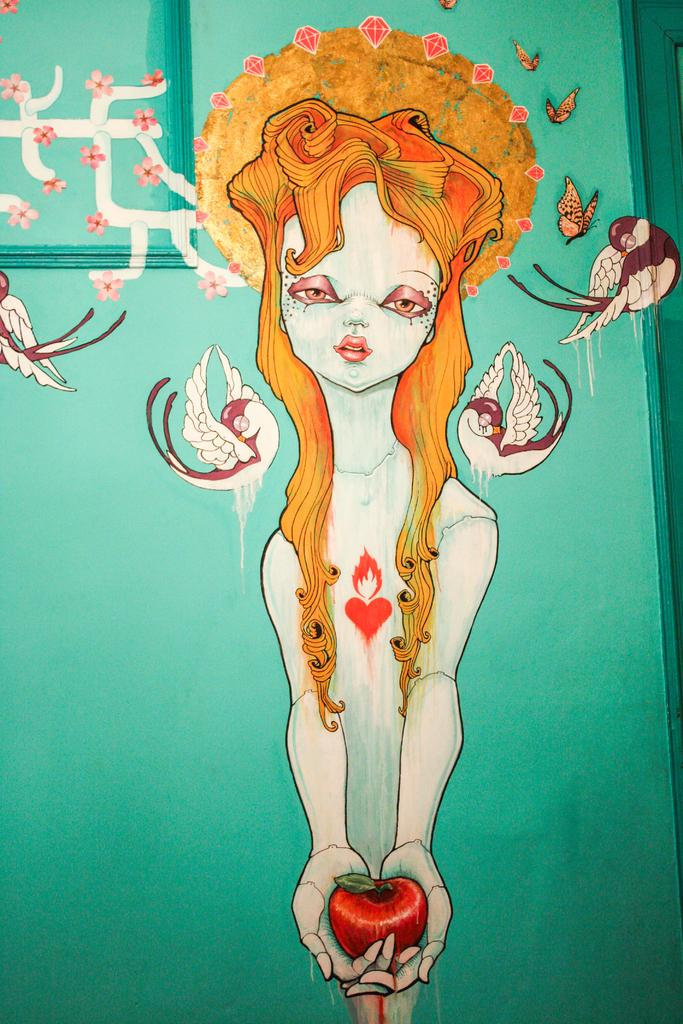What is depicted in the painting in the image? There is a painting of a girl in the image. What is the girl holding in the painting? The girl is holding an apple in the painting. What animals can be seen in the painting? There are birds in the painting. What insects are present in the painting? There are butterflies in the painting. What precious stones are featured in the painting? There are diamonds in the painting. What type of plants are in the painting? There are flowers in the painting. What architectural elements are present in the painting? There are designs on the wall and window door in the painting. What month is the girl celebrating in the painting? There is no indication of a specific month in the painting; it simply depicts a girl holding an apple with various other elements. Can you see the girl kissing someone in the painting? There is no kissing depicted in the painting; the girl is holding an apple and surrounded by other elements. 